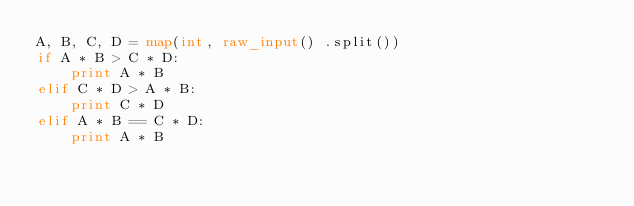Convert code to text. <code><loc_0><loc_0><loc_500><loc_500><_Python_>A, B, C, D = map(int, raw_input() .split())
if A * B > C * D:
    print A * B
elif C * D > A * B:
    print C * D
elif A * B == C * D:
    print A * B
    </code> 